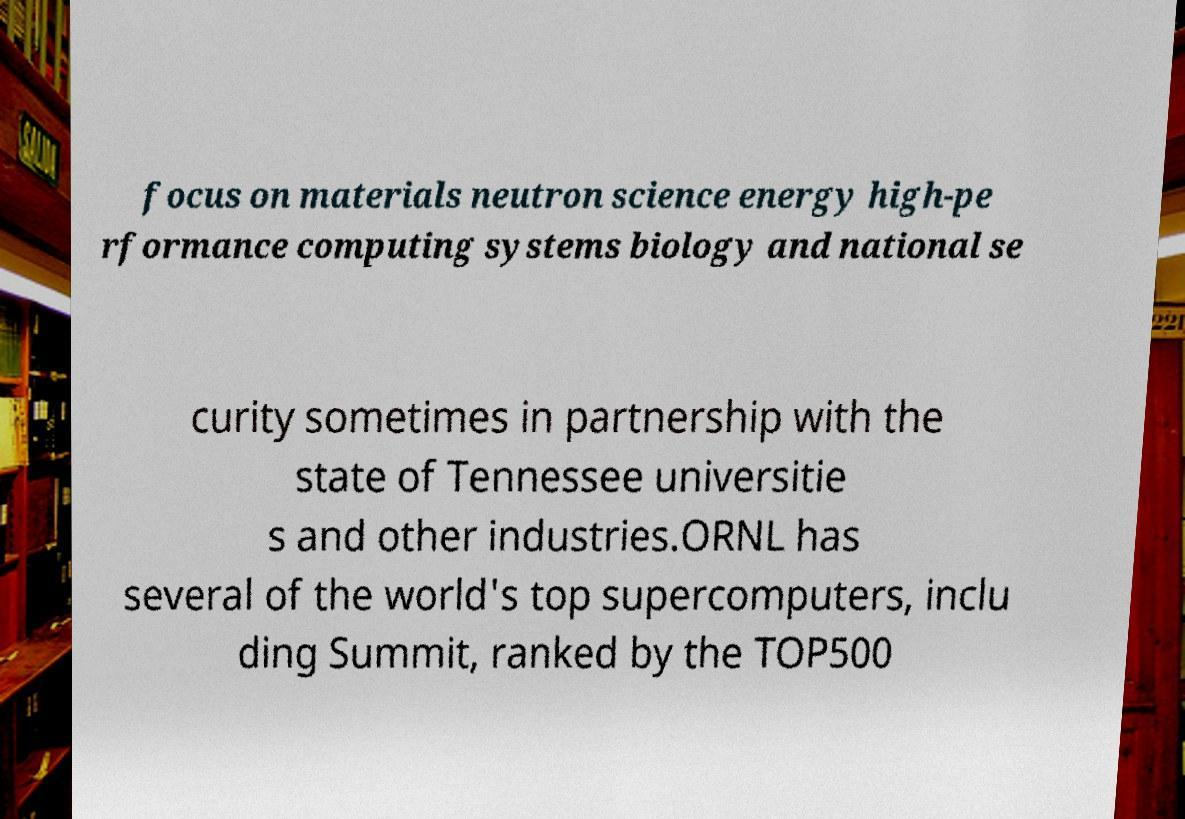Please read and relay the text visible in this image. What does it say? focus on materials neutron science energy high-pe rformance computing systems biology and national se curity sometimes in partnership with the state of Tennessee universitie s and other industries.ORNL has several of the world's top supercomputers, inclu ding Summit, ranked by the TOP500 